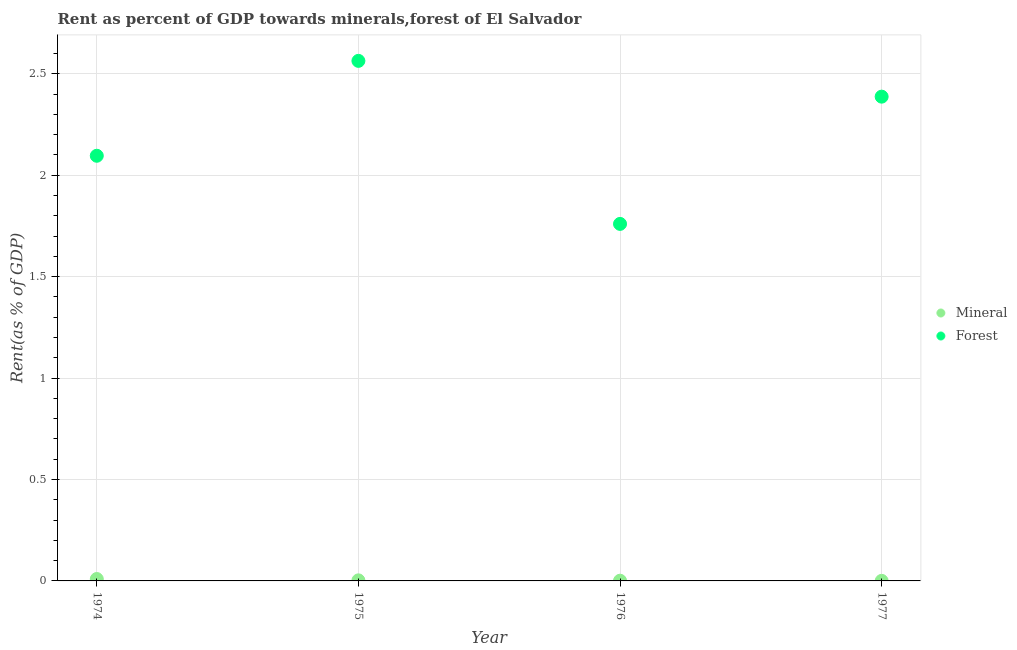How many different coloured dotlines are there?
Keep it short and to the point. 2. Is the number of dotlines equal to the number of legend labels?
Keep it short and to the point. Yes. What is the forest rent in 1977?
Provide a succinct answer. 2.39. Across all years, what is the maximum mineral rent?
Offer a terse response. 0.01. Across all years, what is the minimum forest rent?
Make the answer very short. 1.76. In which year was the mineral rent maximum?
Make the answer very short. 1974. In which year was the forest rent minimum?
Offer a terse response. 1976. What is the total mineral rent in the graph?
Your answer should be compact. 0.01. What is the difference between the mineral rent in 1976 and that in 1977?
Offer a very short reply. 0. What is the difference between the mineral rent in 1975 and the forest rent in 1974?
Provide a short and direct response. -2.09. What is the average mineral rent per year?
Ensure brevity in your answer.  0. In the year 1975, what is the difference between the forest rent and mineral rent?
Provide a succinct answer. 2.56. In how many years, is the forest rent greater than 0.7 %?
Give a very brief answer. 4. What is the ratio of the forest rent in 1975 to that in 1977?
Make the answer very short. 1.07. What is the difference between the highest and the second highest mineral rent?
Give a very brief answer. 0.01. What is the difference between the highest and the lowest mineral rent?
Ensure brevity in your answer.  0.01. In how many years, is the forest rent greater than the average forest rent taken over all years?
Your answer should be compact. 2. Does the forest rent monotonically increase over the years?
Offer a terse response. No. Is the forest rent strictly greater than the mineral rent over the years?
Make the answer very short. Yes. How many years are there in the graph?
Your response must be concise. 4. What is the difference between two consecutive major ticks on the Y-axis?
Give a very brief answer. 0.5. Are the values on the major ticks of Y-axis written in scientific E-notation?
Your answer should be very brief. No. Where does the legend appear in the graph?
Offer a terse response. Center right. How many legend labels are there?
Your answer should be very brief. 2. What is the title of the graph?
Give a very brief answer. Rent as percent of GDP towards minerals,forest of El Salvador. Does "Old" appear as one of the legend labels in the graph?
Provide a succinct answer. No. What is the label or title of the Y-axis?
Your response must be concise. Rent(as % of GDP). What is the Rent(as % of GDP) of Mineral in 1974?
Provide a succinct answer. 0.01. What is the Rent(as % of GDP) of Forest in 1974?
Ensure brevity in your answer.  2.1. What is the Rent(as % of GDP) of Mineral in 1975?
Offer a very short reply. 0. What is the Rent(as % of GDP) in Forest in 1975?
Your response must be concise. 2.56. What is the Rent(as % of GDP) of Mineral in 1976?
Ensure brevity in your answer.  0. What is the Rent(as % of GDP) in Forest in 1976?
Keep it short and to the point. 1.76. What is the Rent(as % of GDP) in Mineral in 1977?
Give a very brief answer. 0. What is the Rent(as % of GDP) of Forest in 1977?
Your answer should be very brief. 2.39. Across all years, what is the maximum Rent(as % of GDP) of Mineral?
Ensure brevity in your answer.  0.01. Across all years, what is the maximum Rent(as % of GDP) of Forest?
Provide a succinct answer. 2.56. Across all years, what is the minimum Rent(as % of GDP) of Mineral?
Provide a succinct answer. 0. Across all years, what is the minimum Rent(as % of GDP) in Forest?
Your answer should be compact. 1.76. What is the total Rent(as % of GDP) of Mineral in the graph?
Your answer should be very brief. 0.01. What is the total Rent(as % of GDP) of Forest in the graph?
Provide a short and direct response. 8.81. What is the difference between the Rent(as % of GDP) in Mineral in 1974 and that in 1975?
Provide a succinct answer. 0.01. What is the difference between the Rent(as % of GDP) in Forest in 1974 and that in 1975?
Give a very brief answer. -0.47. What is the difference between the Rent(as % of GDP) in Mineral in 1974 and that in 1976?
Offer a very short reply. 0.01. What is the difference between the Rent(as % of GDP) of Forest in 1974 and that in 1976?
Provide a succinct answer. 0.34. What is the difference between the Rent(as % of GDP) in Mineral in 1974 and that in 1977?
Offer a terse response. 0.01. What is the difference between the Rent(as % of GDP) in Forest in 1974 and that in 1977?
Your answer should be very brief. -0.29. What is the difference between the Rent(as % of GDP) in Mineral in 1975 and that in 1976?
Ensure brevity in your answer.  0. What is the difference between the Rent(as % of GDP) in Forest in 1975 and that in 1976?
Offer a very short reply. 0.8. What is the difference between the Rent(as % of GDP) of Mineral in 1975 and that in 1977?
Keep it short and to the point. 0. What is the difference between the Rent(as % of GDP) in Forest in 1975 and that in 1977?
Your answer should be compact. 0.18. What is the difference between the Rent(as % of GDP) of Mineral in 1976 and that in 1977?
Make the answer very short. 0. What is the difference between the Rent(as % of GDP) in Forest in 1976 and that in 1977?
Provide a short and direct response. -0.63. What is the difference between the Rent(as % of GDP) of Mineral in 1974 and the Rent(as % of GDP) of Forest in 1975?
Offer a very short reply. -2.55. What is the difference between the Rent(as % of GDP) of Mineral in 1974 and the Rent(as % of GDP) of Forest in 1976?
Offer a terse response. -1.75. What is the difference between the Rent(as % of GDP) of Mineral in 1974 and the Rent(as % of GDP) of Forest in 1977?
Your answer should be compact. -2.38. What is the difference between the Rent(as % of GDP) of Mineral in 1975 and the Rent(as % of GDP) of Forest in 1976?
Your answer should be very brief. -1.76. What is the difference between the Rent(as % of GDP) of Mineral in 1975 and the Rent(as % of GDP) of Forest in 1977?
Your answer should be compact. -2.38. What is the difference between the Rent(as % of GDP) of Mineral in 1976 and the Rent(as % of GDP) of Forest in 1977?
Your answer should be very brief. -2.39. What is the average Rent(as % of GDP) of Mineral per year?
Give a very brief answer. 0. What is the average Rent(as % of GDP) in Forest per year?
Keep it short and to the point. 2.2. In the year 1974, what is the difference between the Rent(as % of GDP) in Mineral and Rent(as % of GDP) in Forest?
Offer a very short reply. -2.09. In the year 1975, what is the difference between the Rent(as % of GDP) in Mineral and Rent(as % of GDP) in Forest?
Your answer should be compact. -2.56. In the year 1976, what is the difference between the Rent(as % of GDP) in Mineral and Rent(as % of GDP) in Forest?
Offer a very short reply. -1.76. In the year 1977, what is the difference between the Rent(as % of GDP) in Mineral and Rent(as % of GDP) in Forest?
Keep it short and to the point. -2.39. What is the ratio of the Rent(as % of GDP) of Mineral in 1974 to that in 1975?
Your response must be concise. 3.37. What is the ratio of the Rent(as % of GDP) in Forest in 1974 to that in 1975?
Provide a succinct answer. 0.82. What is the ratio of the Rent(as % of GDP) of Mineral in 1974 to that in 1976?
Ensure brevity in your answer.  8.59. What is the ratio of the Rent(as % of GDP) of Forest in 1974 to that in 1976?
Your answer should be compact. 1.19. What is the ratio of the Rent(as % of GDP) in Mineral in 1974 to that in 1977?
Your answer should be very brief. 28.91. What is the ratio of the Rent(as % of GDP) in Forest in 1974 to that in 1977?
Ensure brevity in your answer.  0.88. What is the ratio of the Rent(as % of GDP) in Mineral in 1975 to that in 1976?
Your response must be concise. 2.55. What is the ratio of the Rent(as % of GDP) in Forest in 1975 to that in 1976?
Ensure brevity in your answer.  1.46. What is the ratio of the Rent(as % of GDP) of Mineral in 1975 to that in 1977?
Your answer should be very brief. 8.57. What is the ratio of the Rent(as % of GDP) in Forest in 1975 to that in 1977?
Make the answer very short. 1.07. What is the ratio of the Rent(as % of GDP) in Mineral in 1976 to that in 1977?
Your response must be concise. 3.37. What is the ratio of the Rent(as % of GDP) in Forest in 1976 to that in 1977?
Offer a very short reply. 0.74. What is the difference between the highest and the second highest Rent(as % of GDP) in Mineral?
Your response must be concise. 0.01. What is the difference between the highest and the second highest Rent(as % of GDP) in Forest?
Offer a terse response. 0.18. What is the difference between the highest and the lowest Rent(as % of GDP) in Mineral?
Make the answer very short. 0.01. What is the difference between the highest and the lowest Rent(as % of GDP) in Forest?
Ensure brevity in your answer.  0.8. 